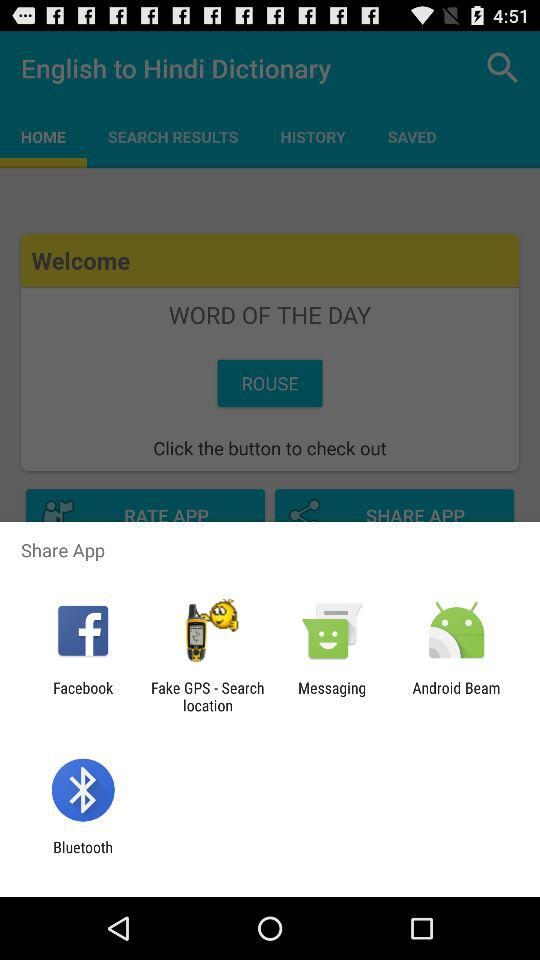Which applications can be used to share? The applications "Facebook", "Fake GPS - Search location", "Messaging", "Android Beam" and "Bluetooth" can be used to share. 